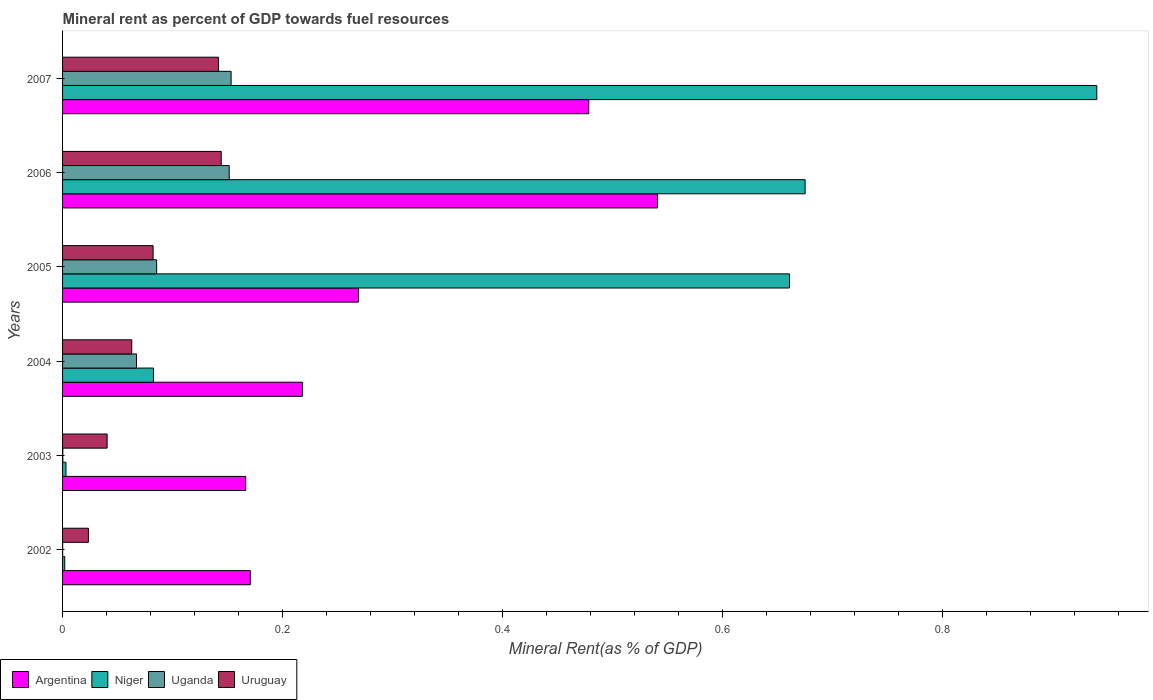How many different coloured bars are there?
Provide a short and direct response. 4. How many bars are there on the 3rd tick from the top?
Provide a succinct answer. 4. How many bars are there on the 1st tick from the bottom?
Give a very brief answer. 4. What is the mineral rent in Argentina in 2005?
Offer a terse response. 0.27. Across all years, what is the maximum mineral rent in Argentina?
Offer a terse response. 0.54. Across all years, what is the minimum mineral rent in Argentina?
Your response must be concise. 0.17. In which year was the mineral rent in Uruguay maximum?
Your answer should be compact. 2006. In which year was the mineral rent in Niger minimum?
Give a very brief answer. 2002. What is the total mineral rent in Argentina in the graph?
Keep it short and to the point. 1.84. What is the difference between the mineral rent in Uruguay in 2003 and that in 2004?
Ensure brevity in your answer.  -0.02. What is the difference between the mineral rent in Uganda in 2004 and the mineral rent in Niger in 2006?
Give a very brief answer. -0.61. What is the average mineral rent in Argentina per year?
Your response must be concise. 0.31. In the year 2006, what is the difference between the mineral rent in Uganda and mineral rent in Argentina?
Your answer should be compact. -0.39. In how many years, is the mineral rent in Argentina greater than 0.44 %?
Keep it short and to the point. 2. What is the ratio of the mineral rent in Uruguay in 2003 to that in 2006?
Provide a short and direct response. 0.28. Is the mineral rent in Argentina in 2004 less than that in 2005?
Keep it short and to the point. Yes. What is the difference between the highest and the second highest mineral rent in Niger?
Your answer should be compact. 0.27. What is the difference between the highest and the lowest mineral rent in Uganda?
Your answer should be compact. 0.15. What does the 2nd bar from the top in 2002 represents?
Ensure brevity in your answer.  Uganda. What does the 1st bar from the bottom in 2002 represents?
Provide a short and direct response. Argentina. Is it the case that in every year, the sum of the mineral rent in Uruguay and mineral rent in Argentina is greater than the mineral rent in Niger?
Make the answer very short. No. How many bars are there?
Give a very brief answer. 24. What is the difference between two consecutive major ticks on the X-axis?
Provide a succinct answer. 0.2. Does the graph contain grids?
Your answer should be compact. No. Where does the legend appear in the graph?
Ensure brevity in your answer.  Bottom left. What is the title of the graph?
Your answer should be very brief. Mineral rent as percent of GDP towards fuel resources. Does "Canada" appear as one of the legend labels in the graph?
Ensure brevity in your answer.  No. What is the label or title of the X-axis?
Keep it short and to the point. Mineral Rent(as % of GDP). What is the Mineral Rent(as % of GDP) of Argentina in 2002?
Provide a succinct answer. 0.17. What is the Mineral Rent(as % of GDP) of Niger in 2002?
Provide a short and direct response. 0. What is the Mineral Rent(as % of GDP) in Uganda in 2002?
Provide a short and direct response. 7.469620528345872e-5. What is the Mineral Rent(as % of GDP) of Uruguay in 2002?
Keep it short and to the point. 0.02. What is the Mineral Rent(as % of GDP) of Argentina in 2003?
Give a very brief answer. 0.17. What is the Mineral Rent(as % of GDP) in Niger in 2003?
Provide a short and direct response. 0. What is the Mineral Rent(as % of GDP) of Uganda in 2003?
Keep it short and to the point. 0. What is the Mineral Rent(as % of GDP) in Uruguay in 2003?
Provide a short and direct response. 0.04. What is the Mineral Rent(as % of GDP) in Argentina in 2004?
Provide a short and direct response. 0.22. What is the Mineral Rent(as % of GDP) in Niger in 2004?
Ensure brevity in your answer.  0.08. What is the Mineral Rent(as % of GDP) in Uganda in 2004?
Give a very brief answer. 0.07. What is the Mineral Rent(as % of GDP) in Uruguay in 2004?
Give a very brief answer. 0.06. What is the Mineral Rent(as % of GDP) in Argentina in 2005?
Offer a terse response. 0.27. What is the Mineral Rent(as % of GDP) in Niger in 2005?
Make the answer very short. 0.66. What is the Mineral Rent(as % of GDP) of Uganda in 2005?
Provide a succinct answer. 0.09. What is the Mineral Rent(as % of GDP) in Uruguay in 2005?
Make the answer very short. 0.08. What is the Mineral Rent(as % of GDP) of Argentina in 2006?
Offer a very short reply. 0.54. What is the Mineral Rent(as % of GDP) in Niger in 2006?
Give a very brief answer. 0.68. What is the Mineral Rent(as % of GDP) of Uganda in 2006?
Provide a succinct answer. 0.15. What is the Mineral Rent(as % of GDP) of Uruguay in 2006?
Provide a short and direct response. 0.14. What is the Mineral Rent(as % of GDP) of Argentina in 2007?
Your answer should be compact. 0.48. What is the Mineral Rent(as % of GDP) of Niger in 2007?
Your answer should be compact. 0.94. What is the Mineral Rent(as % of GDP) in Uganda in 2007?
Keep it short and to the point. 0.15. What is the Mineral Rent(as % of GDP) in Uruguay in 2007?
Keep it short and to the point. 0.14. Across all years, what is the maximum Mineral Rent(as % of GDP) of Argentina?
Give a very brief answer. 0.54. Across all years, what is the maximum Mineral Rent(as % of GDP) of Niger?
Provide a short and direct response. 0.94. Across all years, what is the maximum Mineral Rent(as % of GDP) in Uganda?
Your response must be concise. 0.15. Across all years, what is the maximum Mineral Rent(as % of GDP) of Uruguay?
Provide a short and direct response. 0.14. Across all years, what is the minimum Mineral Rent(as % of GDP) in Argentina?
Provide a short and direct response. 0.17. Across all years, what is the minimum Mineral Rent(as % of GDP) in Niger?
Offer a terse response. 0. Across all years, what is the minimum Mineral Rent(as % of GDP) in Uganda?
Make the answer very short. 7.469620528345872e-5. Across all years, what is the minimum Mineral Rent(as % of GDP) in Uruguay?
Your response must be concise. 0.02. What is the total Mineral Rent(as % of GDP) in Argentina in the graph?
Provide a short and direct response. 1.84. What is the total Mineral Rent(as % of GDP) of Niger in the graph?
Your answer should be compact. 2.36. What is the total Mineral Rent(as % of GDP) of Uganda in the graph?
Offer a terse response. 0.46. What is the total Mineral Rent(as % of GDP) in Uruguay in the graph?
Offer a very short reply. 0.5. What is the difference between the Mineral Rent(as % of GDP) in Argentina in 2002 and that in 2003?
Keep it short and to the point. 0. What is the difference between the Mineral Rent(as % of GDP) in Niger in 2002 and that in 2003?
Your answer should be compact. -0. What is the difference between the Mineral Rent(as % of GDP) in Uganda in 2002 and that in 2003?
Ensure brevity in your answer.  -0. What is the difference between the Mineral Rent(as % of GDP) of Uruguay in 2002 and that in 2003?
Offer a terse response. -0.02. What is the difference between the Mineral Rent(as % of GDP) in Argentina in 2002 and that in 2004?
Keep it short and to the point. -0.05. What is the difference between the Mineral Rent(as % of GDP) of Niger in 2002 and that in 2004?
Your answer should be very brief. -0.08. What is the difference between the Mineral Rent(as % of GDP) in Uganda in 2002 and that in 2004?
Offer a terse response. -0.07. What is the difference between the Mineral Rent(as % of GDP) of Uruguay in 2002 and that in 2004?
Your answer should be very brief. -0.04. What is the difference between the Mineral Rent(as % of GDP) of Argentina in 2002 and that in 2005?
Ensure brevity in your answer.  -0.1. What is the difference between the Mineral Rent(as % of GDP) of Niger in 2002 and that in 2005?
Provide a short and direct response. -0.66. What is the difference between the Mineral Rent(as % of GDP) of Uganda in 2002 and that in 2005?
Keep it short and to the point. -0.09. What is the difference between the Mineral Rent(as % of GDP) of Uruguay in 2002 and that in 2005?
Keep it short and to the point. -0.06. What is the difference between the Mineral Rent(as % of GDP) of Argentina in 2002 and that in 2006?
Offer a very short reply. -0.37. What is the difference between the Mineral Rent(as % of GDP) of Niger in 2002 and that in 2006?
Provide a short and direct response. -0.67. What is the difference between the Mineral Rent(as % of GDP) in Uganda in 2002 and that in 2006?
Keep it short and to the point. -0.15. What is the difference between the Mineral Rent(as % of GDP) of Uruguay in 2002 and that in 2006?
Offer a terse response. -0.12. What is the difference between the Mineral Rent(as % of GDP) of Argentina in 2002 and that in 2007?
Offer a terse response. -0.31. What is the difference between the Mineral Rent(as % of GDP) in Niger in 2002 and that in 2007?
Provide a succinct answer. -0.94. What is the difference between the Mineral Rent(as % of GDP) of Uganda in 2002 and that in 2007?
Make the answer very short. -0.15. What is the difference between the Mineral Rent(as % of GDP) of Uruguay in 2002 and that in 2007?
Make the answer very short. -0.12. What is the difference between the Mineral Rent(as % of GDP) in Argentina in 2003 and that in 2004?
Your answer should be very brief. -0.05. What is the difference between the Mineral Rent(as % of GDP) in Niger in 2003 and that in 2004?
Provide a succinct answer. -0.08. What is the difference between the Mineral Rent(as % of GDP) in Uganda in 2003 and that in 2004?
Your response must be concise. -0.07. What is the difference between the Mineral Rent(as % of GDP) in Uruguay in 2003 and that in 2004?
Make the answer very short. -0.02. What is the difference between the Mineral Rent(as % of GDP) of Argentina in 2003 and that in 2005?
Provide a succinct answer. -0.1. What is the difference between the Mineral Rent(as % of GDP) in Niger in 2003 and that in 2005?
Offer a terse response. -0.66. What is the difference between the Mineral Rent(as % of GDP) in Uganda in 2003 and that in 2005?
Keep it short and to the point. -0.09. What is the difference between the Mineral Rent(as % of GDP) in Uruguay in 2003 and that in 2005?
Your answer should be compact. -0.04. What is the difference between the Mineral Rent(as % of GDP) of Argentina in 2003 and that in 2006?
Provide a succinct answer. -0.37. What is the difference between the Mineral Rent(as % of GDP) of Niger in 2003 and that in 2006?
Provide a short and direct response. -0.67. What is the difference between the Mineral Rent(as % of GDP) in Uganda in 2003 and that in 2006?
Your answer should be compact. -0.15. What is the difference between the Mineral Rent(as % of GDP) of Uruguay in 2003 and that in 2006?
Offer a terse response. -0.1. What is the difference between the Mineral Rent(as % of GDP) of Argentina in 2003 and that in 2007?
Your response must be concise. -0.31. What is the difference between the Mineral Rent(as % of GDP) in Niger in 2003 and that in 2007?
Your answer should be very brief. -0.94. What is the difference between the Mineral Rent(as % of GDP) in Uganda in 2003 and that in 2007?
Offer a terse response. -0.15. What is the difference between the Mineral Rent(as % of GDP) in Uruguay in 2003 and that in 2007?
Your response must be concise. -0.1. What is the difference between the Mineral Rent(as % of GDP) of Argentina in 2004 and that in 2005?
Make the answer very short. -0.05. What is the difference between the Mineral Rent(as % of GDP) of Niger in 2004 and that in 2005?
Make the answer very short. -0.58. What is the difference between the Mineral Rent(as % of GDP) of Uganda in 2004 and that in 2005?
Provide a succinct answer. -0.02. What is the difference between the Mineral Rent(as % of GDP) in Uruguay in 2004 and that in 2005?
Your answer should be very brief. -0.02. What is the difference between the Mineral Rent(as % of GDP) of Argentina in 2004 and that in 2006?
Provide a succinct answer. -0.32. What is the difference between the Mineral Rent(as % of GDP) of Niger in 2004 and that in 2006?
Your answer should be compact. -0.59. What is the difference between the Mineral Rent(as % of GDP) in Uganda in 2004 and that in 2006?
Ensure brevity in your answer.  -0.08. What is the difference between the Mineral Rent(as % of GDP) of Uruguay in 2004 and that in 2006?
Provide a succinct answer. -0.08. What is the difference between the Mineral Rent(as % of GDP) of Argentina in 2004 and that in 2007?
Your answer should be compact. -0.26. What is the difference between the Mineral Rent(as % of GDP) of Niger in 2004 and that in 2007?
Your answer should be compact. -0.86. What is the difference between the Mineral Rent(as % of GDP) in Uganda in 2004 and that in 2007?
Your response must be concise. -0.09. What is the difference between the Mineral Rent(as % of GDP) in Uruguay in 2004 and that in 2007?
Your answer should be compact. -0.08. What is the difference between the Mineral Rent(as % of GDP) of Argentina in 2005 and that in 2006?
Make the answer very short. -0.27. What is the difference between the Mineral Rent(as % of GDP) in Niger in 2005 and that in 2006?
Offer a terse response. -0.01. What is the difference between the Mineral Rent(as % of GDP) of Uganda in 2005 and that in 2006?
Your answer should be very brief. -0.07. What is the difference between the Mineral Rent(as % of GDP) of Uruguay in 2005 and that in 2006?
Provide a succinct answer. -0.06. What is the difference between the Mineral Rent(as % of GDP) of Argentina in 2005 and that in 2007?
Give a very brief answer. -0.21. What is the difference between the Mineral Rent(as % of GDP) of Niger in 2005 and that in 2007?
Make the answer very short. -0.28. What is the difference between the Mineral Rent(as % of GDP) in Uganda in 2005 and that in 2007?
Your answer should be compact. -0.07. What is the difference between the Mineral Rent(as % of GDP) of Uruguay in 2005 and that in 2007?
Offer a terse response. -0.06. What is the difference between the Mineral Rent(as % of GDP) in Argentina in 2006 and that in 2007?
Provide a succinct answer. 0.06. What is the difference between the Mineral Rent(as % of GDP) of Niger in 2006 and that in 2007?
Make the answer very short. -0.27. What is the difference between the Mineral Rent(as % of GDP) in Uganda in 2006 and that in 2007?
Give a very brief answer. -0. What is the difference between the Mineral Rent(as % of GDP) in Uruguay in 2006 and that in 2007?
Offer a terse response. 0. What is the difference between the Mineral Rent(as % of GDP) in Argentina in 2002 and the Mineral Rent(as % of GDP) in Niger in 2003?
Make the answer very short. 0.17. What is the difference between the Mineral Rent(as % of GDP) of Argentina in 2002 and the Mineral Rent(as % of GDP) of Uganda in 2003?
Offer a very short reply. 0.17. What is the difference between the Mineral Rent(as % of GDP) in Argentina in 2002 and the Mineral Rent(as % of GDP) in Uruguay in 2003?
Make the answer very short. 0.13. What is the difference between the Mineral Rent(as % of GDP) of Niger in 2002 and the Mineral Rent(as % of GDP) of Uganda in 2003?
Your answer should be compact. 0. What is the difference between the Mineral Rent(as % of GDP) in Niger in 2002 and the Mineral Rent(as % of GDP) in Uruguay in 2003?
Give a very brief answer. -0.04. What is the difference between the Mineral Rent(as % of GDP) of Uganda in 2002 and the Mineral Rent(as % of GDP) of Uruguay in 2003?
Offer a terse response. -0.04. What is the difference between the Mineral Rent(as % of GDP) in Argentina in 2002 and the Mineral Rent(as % of GDP) in Niger in 2004?
Provide a short and direct response. 0.09. What is the difference between the Mineral Rent(as % of GDP) in Argentina in 2002 and the Mineral Rent(as % of GDP) in Uganda in 2004?
Keep it short and to the point. 0.1. What is the difference between the Mineral Rent(as % of GDP) of Argentina in 2002 and the Mineral Rent(as % of GDP) of Uruguay in 2004?
Give a very brief answer. 0.11. What is the difference between the Mineral Rent(as % of GDP) in Niger in 2002 and the Mineral Rent(as % of GDP) in Uganda in 2004?
Your response must be concise. -0.07. What is the difference between the Mineral Rent(as % of GDP) in Niger in 2002 and the Mineral Rent(as % of GDP) in Uruguay in 2004?
Your response must be concise. -0.06. What is the difference between the Mineral Rent(as % of GDP) in Uganda in 2002 and the Mineral Rent(as % of GDP) in Uruguay in 2004?
Offer a terse response. -0.06. What is the difference between the Mineral Rent(as % of GDP) of Argentina in 2002 and the Mineral Rent(as % of GDP) of Niger in 2005?
Make the answer very short. -0.49. What is the difference between the Mineral Rent(as % of GDP) of Argentina in 2002 and the Mineral Rent(as % of GDP) of Uganda in 2005?
Offer a very short reply. 0.09. What is the difference between the Mineral Rent(as % of GDP) in Argentina in 2002 and the Mineral Rent(as % of GDP) in Uruguay in 2005?
Offer a very short reply. 0.09. What is the difference between the Mineral Rent(as % of GDP) of Niger in 2002 and the Mineral Rent(as % of GDP) of Uganda in 2005?
Ensure brevity in your answer.  -0.08. What is the difference between the Mineral Rent(as % of GDP) in Niger in 2002 and the Mineral Rent(as % of GDP) in Uruguay in 2005?
Offer a very short reply. -0.08. What is the difference between the Mineral Rent(as % of GDP) in Uganda in 2002 and the Mineral Rent(as % of GDP) in Uruguay in 2005?
Make the answer very short. -0.08. What is the difference between the Mineral Rent(as % of GDP) of Argentina in 2002 and the Mineral Rent(as % of GDP) of Niger in 2006?
Your answer should be very brief. -0.5. What is the difference between the Mineral Rent(as % of GDP) in Argentina in 2002 and the Mineral Rent(as % of GDP) in Uganda in 2006?
Your response must be concise. 0.02. What is the difference between the Mineral Rent(as % of GDP) of Argentina in 2002 and the Mineral Rent(as % of GDP) of Uruguay in 2006?
Offer a very short reply. 0.03. What is the difference between the Mineral Rent(as % of GDP) in Niger in 2002 and the Mineral Rent(as % of GDP) in Uganda in 2006?
Keep it short and to the point. -0.15. What is the difference between the Mineral Rent(as % of GDP) in Niger in 2002 and the Mineral Rent(as % of GDP) in Uruguay in 2006?
Provide a succinct answer. -0.14. What is the difference between the Mineral Rent(as % of GDP) in Uganda in 2002 and the Mineral Rent(as % of GDP) in Uruguay in 2006?
Keep it short and to the point. -0.14. What is the difference between the Mineral Rent(as % of GDP) in Argentina in 2002 and the Mineral Rent(as % of GDP) in Niger in 2007?
Offer a terse response. -0.77. What is the difference between the Mineral Rent(as % of GDP) of Argentina in 2002 and the Mineral Rent(as % of GDP) of Uganda in 2007?
Your answer should be compact. 0.02. What is the difference between the Mineral Rent(as % of GDP) of Argentina in 2002 and the Mineral Rent(as % of GDP) of Uruguay in 2007?
Your response must be concise. 0.03. What is the difference between the Mineral Rent(as % of GDP) in Niger in 2002 and the Mineral Rent(as % of GDP) in Uganda in 2007?
Keep it short and to the point. -0.15. What is the difference between the Mineral Rent(as % of GDP) of Niger in 2002 and the Mineral Rent(as % of GDP) of Uruguay in 2007?
Ensure brevity in your answer.  -0.14. What is the difference between the Mineral Rent(as % of GDP) of Uganda in 2002 and the Mineral Rent(as % of GDP) of Uruguay in 2007?
Your response must be concise. -0.14. What is the difference between the Mineral Rent(as % of GDP) of Argentina in 2003 and the Mineral Rent(as % of GDP) of Niger in 2004?
Your response must be concise. 0.08. What is the difference between the Mineral Rent(as % of GDP) of Argentina in 2003 and the Mineral Rent(as % of GDP) of Uganda in 2004?
Ensure brevity in your answer.  0.1. What is the difference between the Mineral Rent(as % of GDP) in Argentina in 2003 and the Mineral Rent(as % of GDP) in Uruguay in 2004?
Your answer should be very brief. 0.1. What is the difference between the Mineral Rent(as % of GDP) in Niger in 2003 and the Mineral Rent(as % of GDP) in Uganda in 2004?
Provide a succinct answer. -0.06. What is the difference between the Mineral Rent(as % of GDP) of Niger in 2003 and the Mineral Rent(as % of GDP) of Uruguay in 2004?
Offer a very short reply. -0.06. What is the difference between the Mineral Rent(as % of GDP) in Uganda in 2003 and the Mineral Rent(as % of GDP) in Uruguay in 2004?
Keep it short and to the point. -0.06. What is the difference between the Mineral Rent(as % of GDP) in Argentina in 2003 and the Mineral Rent(as % of GDP) in Niger in 2005?
Give a very brief answer. -0.49. What is the difference between the Mineral Rent(as % of GDP) in Argentina in 2003 and the Mineral Rent(as % of GDP) in Uganda in 2005?
Your answer should be compact. 0.08. What is the difference between the Mineral Rent(as % of GDP) of Argentina in 2003 and the Mineral Rent(as % of GDP) of Uruguay in 2005?
Your response must be concise. 0.08. What is the difference between the Mineral Rent(as % of GDP) in Niger in 2003 and the Mineral Rent(as % of GDP) in Uganda in 2005?
Ensure brevity in your answer.  -0.08. What is the difference between the Mineral Rent(as % of GDP) of Niger in 2003 and the Mineral Rent(as % of GDP) of Uruguay in 2005?
Your answer should be compact. -0.08. What is the difference between the Mineral Rent(as % of GDP) in Uganda in 2003 and the Mineral Rent(as % of GDP) in Uruguay in 2005?
Your answer should be compact. -0.08. What is the difference between the Mineral Rent(as % of GDP) of Argentina in 2003 and the Mineral Rent(as % of GDP) of Niger in 2006?
Ensure brevity in your answer.  -0.51. What is the difference between the Mineral Rent(as % of GDP) in Argentina in 2003 and the Mineral Rent(as % of GDP) in Uganda in 2006?
Your answer should be very brief. 0.01. What is the difference between the Mineral Rent(as % of GDP) of Argentina in 2003 and the Mineral Rent(as % of GDP) of Uruguay in 2006?
Offer a terse response. 0.02. What is the difference between the Mineral Rent(as % of GDP) in Niger in 2003 and the Mineral Rent(as % of GDP) in Uganda in 2006?
Make the answer very short. -0.15. What is the difference between the Mineral Rent(as % of GDP) in Niger in 2003 and the Mineral Rent(as % of GDP) in Uruguay in 2006?
Ensure brevity in your answer.  -0.14. What is the difference between the Mineral Rent(as % of GDP) of Uganda in 2003 and the Mineral Rent(as % of GDP) of Uruguay in 2006?
Offer a very short reply. -0.14. What is the difference between the Mineral Rent(as % of GDP) in Argentina in 2003 and the Mineral Rent(as % of GDP) in Niger in 2007?
Make the answer very short. -0.77. What is the difference between the Mineral Rent(as % of GDP) of Argentina in 2003 and the Mineral Rent(as % of GDP) of Uganda in 2007?
Ensure brevity in your answer.  0.01. What is the difference between the Mineral Rent(as % of GDP) of Argentina in 2003 and the Mineral Rent(as % of GDP) of Uruguay in 2007?
Keep it short and to the point. 0.02. What is the difference between the Mineral Rent(as % of GDP) of Niger in 2003 and the Mineral Rent(as % of GDP) of Uganda in 2007?
Offer a very short reply. -0.15. What is the difference between the Mineral Rent(as % of GDP) in Niger in 2003 and the Mineral Rent(as % of GDP) in Uruguay in 2007?
Keep it short and to the point. -0.14. What is the difference between the Mineral Rent(as % of GDP) of Uganda in 2003 and the Mineral Rent(as % of GDP) of Uruguay in 2007?
Give a very brief answer. -0.14. What is the difference between the Mineral Rent(as % of GDP) in Argentina in 2004 and the Mineral Rent(as % of GDP) in Niger in 2005?
Your response must be concise. -0.44. What is the difference between the Mineral Rent(as % of GDP) of Argentina in 2004 and the Mineral Rent(as % of GDP) of Uganda in 2005?
Your response must be concise. 0.13. What is the difference between the Mineral Rent(as % of GDP) of Argentina in 2004 and the Mineral Rent(as % of GDP) of Uruguay in 2005?
Your response must be concise. 0.14. What is the difference between the Mineral Rent(as % of GDP) in Niger in 2004 and the Mineral Rent(as % of GDP) in Uganda in 2005?
Offer a very short reply. -0. What is the difference between the Mineral Rent(as % of GDP) of Uganda in 2004 and the Mineral Rent(as % of GDP) of Uruguay in 2005?
Ensure brevity in your answer.  -0.02. What is the difference between the Mineral Rent(as % of GDP) of Argentina in 2004 and the Mineral Rent(as % of GDP) of Niger in 2006?
Give a very brief answer. -0.46. What is the difference between the Mineral Rent(as % of GDP) in Argentina in 2004 and the Mineral Rent(as % of GDP) in Uganda in 2006?
Your answer should be very brief. 0.07. What is the difference between the Mineral Rent(as % of GDP) of Argentina in 2004 and the Mineral Rent(as % of GDP) of Uruguay in 2006?
Your response must be concise. 0.07. What is the difference between the Mineral Rent(as % of GDP) in Niger in 2004 and the Mineral Rent(as % of GDP) in Uganda in 2006?
Offer a terse response. -0.07. What is the difference between the Mineral Rent(as % of GDP) of Niger in 2004 and the Mineral Rent(as % of GDP) of Uruguay in 2006?
Provide a short and direct response. -0.06. What is the difference between the Mineral Rent(as % of GDP) in Uganda in 2004 and the Mineral Rent(as % of GDP) in Uruguay in 2006?
Your answer should be compact. -0.08. What is the difference between the Mineral Rent(as % of GDP) of Argentina in 2004 and the Mineral Rent(as % of GDP) of Niger in 2007?
Your answer should be compact. -0.72. What is the difference between the Mineral Rent(as % of GDP) of Argentina in 2004 and the Mineral Rent(as % of GDP) of Uganda in 2007?
Keep it short and to the point. 0.06. What is the difference between the Mineral Rent(as % of GDP) of Argentina in 2004 and the Mineral Rent(as % of GDP) of Uruguay in 2007?
Give a very brief answer. 0.08. What is the difference between the Mineral Rent(as % of GDP) in Niger in 2004 and the Mineral Rent(as % of GDP) in Uganda in 2007?
Make the answer very short. -0.07. What is the difference between the Mineral Rent(as % of GDP) in Niger in 2004 and the Mineral Rent(as % of GDP) in Uruguay in 2007?
Provide a succinct answer. -0.06. What is the difference between the Mineral Rent(as % of GDP) in Uganda in 2004 and the Mineral Rent(as % of GDP) in Uruguay in 2007?
Ensure brevity in your answer.  -0.07. What is the difference between the Mineral Rent(as % of GDP) in Argentina in 2005 and the Mineral Rent(as % of GDP) in Niger in 2006?
Provide a short and direct response. -0.41. What is the difference between the Mineral Rent(as % of GDP) of Argentina in 2005 and the Mineral Rent(as % of GDP) of Uganda in 2006?
Keep it short and to the point. 0.12. What is the difference between the Mineral Rent(as % of GDP) in Argentina in 2005 and the Mineral Rent(as % of GDP) in Uruguay in 2006?
Make the answer very short. 0.12. What is the difference between the Mineral Rent(as % of GDP) of Niger in 2005 and the Mineral Rent(as % of GDP) of Uganda in 2006?
Give a very brief answer. 0.51. What is the difference between the Mineral Rent(as % of GDP) of Niger in 2005 and the Mineral Rent(as % of GDP) of Uruguay in 2006?
Keep it short and to the point. 0.52. What is the difference between the Mineral Rent(as % of GDP) of Uganda in 2005 and the Mineral Rent(as % of GDP) of Uruguay in 2006?
Provide a short and direct response. -0.06. What is the difference between the Mineral Rent(as % of GDP) of Argentina in 2005 and the Mineral Rent(as % of GDP) of Niger in 2007?
Give a very brief answer. -0.67. What is the difference between the Mineral Rent(as % of GDP) in Argentina in 2005 and the Mineral Rent(as % of GDP) in Uganda in 2007?
Make the answer very short. 0.12. What is the difference between the Mineral Rent(as % of GDP) in Argentina in 2005 and the Mineral Rent(as % of GDP) in Uruguay in 2007?
Keep it short and to the point. 0.13. What is the difference between the Mineral Rent(as % of GDP) in Niger in 2005 and the Mineral Rent(as % of GDP) in Uganda in 2007?
Ensure brevity in your answer.  0.51. What is the difference between the Mineral Rent(as % of GDP) of Niger in 2005 and the Mineral Rent(as % of GDP) of Uruguay in 2007?
Your answer should be very brief. 0.52. What is the difference between the Mineral Rent(as % of GDP) of Uganda in 2005 and the Mineral Rent(as % of GDP) of Uruguay in 2007?
Give a very brief answer. -0.06. What is the difference between the Mineral Rent(as % of GDP) of Argentina in 2006 and the Mineral Rent(as % of GDP) of Niger in 2007?
Your answer should be very brief. -0.4. What is the difference between the Mineral Rent(as % of GDP) of Argentina in 2006 and the Mineral Rent(as % of GDP) of Uganda in 2007?
Make the answer very short. 0.39. What is the difference between the Mineral Rent(as % of GDP) of Argentina in 2006 and the Mineral Rent(as % of GDP) of Uruguay in 2007?
Make the answer very short. 0.4. What is the difference between the Mineral Rent(as % of GDP) of Niger in 2006 and the Mineral Rent(as % of GDP) of Uganda in 2007?
Your answer should be very brief. 0.52. What is the difference between the Mineral Rent(as % of GDP) in Niger in 2006 and the Mineral Rent(as % of GDP) in Uruguay in 2007?
Your response must be concise. 0.53. What is the difference between the Mineral Rent(as % of GDP) in Uganda in 2006 and the Mineral Rent(as % of GDP) in Uruguay in 2007?
Give a very brief answer. 0.01. What is the average Mineral Rent(as % of GDP) in Argentina per year?
Ensure brevity in your answer.  0.31. What is the average Mineral Rent(as % of GDP) in Niger per year?
Offer a very short reply. 0.39. What is the average Mineral Rent(as % of GDP) of Uganda per year?
Keep it short and to the point. 0.08. What is the average Mineral Rent(as % of GDP) in Uruguay per year?
Give a very brief answer. 0.08. In the year 2002, what is the difference between the Mineral Rent(as % of GDP) in Argentina and Mineral Rent(as % of GDP) in Niger?
Provide a succinct answer. 0.17. In the year 2002, what is the difference between the Mineral Rent(as % of GDP) of Argentina and Mineral Rent(as % of GDP) of Uganda?
Keep it short and to the point. 0.17. In the year 2002, what is the difference between the Mineral Rent(as % of GDP) of Argentina and Mineral Rent(as % of GDP) of Uruguay?
Provide a short and direct response. 0.15. In the year 2002, what is the difference between the Mineral Rent(as % of GDP) of Niger and Mineral Rent(as % of GDP) of Uganda?
Offer a very short reply. 0. In the year 2002, what is the difference between the Mineral Rent(as % of GDP) of Niger and Mineral Rent(as % of GDP) of Uruguay?
Provide a succinct answer. -0.02. In the year 2002, what is the difference between the Mineral Rent(as % of GDP) of Uganda and Mineral Rent(as % of GDP) of Uruguay?
Give a very brief answer. -0.02. In the year 2003, what is the difference between the Mineral Rent(as % of GDP) of Argentina and Mineral Rent(as % of GDP) of Niger?
Provide a succinct answer. 0.16. In the year 2003, what is the difference between the Mineral Rent(as % of GDP) of Argentina and Mineral Rent(as % of GDP) of Uganda?
Make the answer very short. 0.17. In the year 2003, what is the difference between the Mineral Rent(as % of GDP) of Argentina and Mineral Rent(as % of GDP) of Uruguay?
Give a very brief answer. 0.13. In the year 2003, what is the difference between the Mineral Rent(as % of GDP) of Niger and Mineral Rent(as % of GDP) of Uganda?
Provide a succinct answer. 0. In the year 2003, what is the difference between the Mineral Rent(as % of GDP) in Niger and Mineral Rent(as % of GDP) in Uruguay?
Ensure brevity in your answer.  -0.04. In the year 2003, what is the difference between the Mineral Rent(as % of GDP) in Uganda and Mineral Rent(as % of GDP) in Uruguay?
Offer a very short reply. -0.04. In the year 2004, what is the difference between the Mineral Rent(as % of GDP) in Argentina and Mineral Rent(as % of GDP) in Niger?
Your answer should be very brief. 0.14. In the year 2004, what is the difference between the Mineral Rent(as % of GDP) in Argentina and Mineral Rent(as % of GDP) in Uganda?
Offer a terse response. 0.15. In the year 2004, what is the difference between the Mineral Rent(as % of GDP) in Argentina and Mineral Rent(as % of GDP) in Uruguay?
Provide a succinct answer. 0.16. In the year 2004, what is the difference between the Mineral Rent(as % of GDP) of Niger and Mineral Rent(as % of GDP) of Uganda?
Provide a short and direct response. 0.02. In the year 2004, what is the difference between the Mineral Rent(as % of GDP) in Niger and Mineral Rent(as % of GDP) in Uruguay?
Ensure brevity in your answer.  0.02. In the year 2004, what is the difference between the Mineral Rent(as % of GDP) of Uganda and Mineral Rent(as % of GDP) of Uruguay?
Your response must be concise. 0. In the year 2005, what is the difference between the Mineral Rent(as % of GDP) in Argentina and Mineral Rent(as % of GDP) in Niger?
Offer a terse response. -0.39. In the year 2005, what is the difference between the Mineral Rent(as % of GDP) in Argentina and Mineral Rent(as % of GDP) in Uganda?
Offer a very short reply. 0.18. In the year 2005, what is the difference between the Mineral Rent(as % of GDP) in Argentina and Mineral Rent(as % of GDP) in Uruguay?
Your response must be concise. 0.19. In the year 2005, what is the difference between the Mineral Rent(as % of GDP) of Niger and Mineral Rent(as % of GDP) of Uganda?
Your response must be concise. 0.58. In the year 2005, what is the difference between the Mineral Rent(as % of GDP) of Niger and Mineral Rent(as % of GDP) of Uruguay?
Give a very brief answer. 0.58. In the year 2005, what is the difference between the Mineral Rent(as % of GDP) in Uganda and Mineral Rent(as % of GDP) in Uruguay?
Your response must be concise. 0. In the year 2006, what is the difference between the Mineral Rent(as % of GDP) of Argentina and Mineral Rent(as % of GDP) of Niger?
Make the answer very short. -0.13. In the year 2006, what is the difference between the Mineral Rent(as % of GDP) in Argentina and Mineral Rent(as % of GDP) in Uganda?
Offer a terse response. 0.39. In the year 2006, what is the difference between the Mineral Rent(as % of GDP) of Argentina and Mineral Rent(as % of GDP) of Uruguay?
Your response must be concise. 0.4. In the year 2006, what is the difference between the Mineral Rent(as % of GDP) of Niger and Mineral Rent(as % of GDP) of Uganda?
Ensure brevity in your answer.  0.52. In the year 2006, what is the difference between the Mineral Rent(as % of GDP) in Niger and Mineral Rent(as % of GDP) in Uruguay?
Ensure brevity in your answer.  0.53. In the year 2006, what is the difference between the Mineral Rent(as % of GDP) in Uganda and Mineral Rent(as % of GDP) in Uruguay?
Your response must be concise. 0.01. In the year 2007, what is the difference between the Mineral Rent(as % of GDP) of Argentina and Mineral Rent(as % of GDP) of Niger?
Provide a short and direct response. -0.46. In the year 2007, what is the difference between the Mineral Rent(as % of GDP) in Argentina and Mineral Rent(as % of GDP) in Uganda?
Offer a very short reply. 0.33. In the year 2007, what is the difference between the Mineral Rent(as % of GDP) in Argentina and Mineral Rent(as % of GDP) in Uruguay?
Offer a terse response. 0.34. In the year 2007, what is the difference between the Mineral Rent(as % of GDP) in Niger and Mineral Rent(as % of GDP) in Uganda?
Provide a succinct answer. 0.79. In the year 2007, what is the difference between the Mineral Rent(as % of GDP) in Niger and Mineral Rent(as % of GDP) in Uruguay?
Offer a very short reply. 0.8. In the year 2007, what is the difference between the Mineral Rent(as % of GDP) in Uganda and Mineral Rent(as % of GDP) in Uruguay?
Your answer should be very brief. 0.01. What is the ratio of the Mineral Rent(as % of GDP) of Argentina in 2002 to that in 2003?
Offer a terse response. 1.03. What is the ratio of the Mineral Rent(as % of GDP) in Niger in 2002 to that in 2003?
Your response must be concise. 0.64. What is the ratio of the Mineral Rent(as % of GDP) in Uganda in 2002 to that in 2003?
Give a very brief answer. 0.34. What is the ratio of the Mineral Rent(as % of GDP) of Uruguay in 2002 to that in 2003?
Offer a very short reply. 0.58. What is the ratio of the Mineral Rent(as % of GDP) of Argentina in 2002 to that in 2004?
Offer a very short reply. 0.78. What is the ratio of the Mineral Rent(as % of GDP) of Niger in 2002 to that in 2004?
Give a very brief answer. 0.02. What is the ratio of the Mineral Rent(as % of GDP) of Uganda in 2002 to that in 2004?
Make the answer very short. 0. What is the ratio of the Mineral Rent(as % of GDP) of Uruguay in 2002 to that in 2004?
Provide a succinct answer. 0.37. What is the ratio of the Mineral Rent(as % of GDP) in Argentina in 2002 to that in 2005?
Give a very brief answer. 0.63. What is the ratio of the Mineral Rent(as % of GDP) in Niger in 2002 to that in 2005?
Keep it short and to the point. 0. What is the ratio of the Mineral Rent(as % of GDP) of Uganda in 2002 to that in 2005?
Offer a terse response. 0. What is the ratio of the Mineral Rent(as % of GDP) in Uruguay in 2002 to that in 2005?
Ensure brevity in your answer.  0.29. What is the ratio of the Mineral Rent(as % of GDP) of Argentina in 2002 to that in 2006?
Ensure brevity in your answer.  0.32. What is the ratio of the Mineral Rent(as % of GDP) of Niger in 2002 to that in 2006?
Keep it short and to the point. 0. What is the ratio of the Mineral Rent(as % of GDP) in Uruguay in 2002 to that in 2006?
Keep it short and to the point. 0.16. What is the ratio of the Mineral Rent(as % of GDP) in Argentina in 2002 to that in 2007?
Ensure brevity in your answer.  0.36. What is the ratio of the Mineral Rent(as % of GDP) in Niger in 2002 to that in 2007?
Make the answer very short. 0. What is the ratio of the Mineral Rent(as % of GDP) of Uruguay in 2002 to that in 2007?
Your answer should be compact. 0.17. What is the ratio of the Mineral Rent(as % of GDP) in Argentina in 2003 to that in 2004?
Your answer should be very brief. 0.76. What is the ratio of the Mineral Rent(as % of GDP) of Niger in 2003 to that in 2004?
Your answer should be compact. 0.04. What is the ratio of the Mineral Rent(as % of GDP) of Uganda in 2003 to that in 2004?
Your response must be concise. 0. What is the ratio of the Mineral Rent(as % of GDP) of Uruguay in 2003 to that in 2004?
Offer a terse response. 0.64. What is the ratio of the Mineral Rent(as % of GDP) of Argentina in 2003 to that in 2005?
Provide a succinct answer. 0.62. What is the ratio of the Mineral Rent(as % of GDP) of Niger in 2003 to that in 2005?
Your answer should be very brief. 0. What is the ratio of the Mineral Rent(as % of GDP) of Uganda in 2003 to that in 2005?
Give a very brief answer. 0. What is the ratio of the Mineral Rent(as % of GDP) in Uruguay in 2003 to that in 2005?
Offer a very short reply. 0.49. What is the ratio of the Mineral Rent(as % of GDP) of Argentina in 2003 to that in 2006?
Offer a terse response. 0.31. What is the ratio of the Mineral Rent(as % of GDP) in Niger in 2003 to that in 2006?
Your answer should be very brief. 0. What is the ratio of the Mineral Rent(as % of GDP) of Uganda in 2003 to that in 2006?
Your answer should be compact. 0. What is the ratio of the Mineral Rent(as % of GDP) of Uruguay in 2003 to that in 2006?
Offer a terse response. 0.28. What is the ratio of the Mineral Rent(as % of GDP) in Argentina in 2003 to that in 2007?
Offer a very short reply. 0.35. What is the ratio of the Mineral Rent(as % of GDP) in Niger in 2003 to that in 2007?
Ensure brevity in your answer.  0. What is the ratio of the Mineral Rent(as % of GDP) of Uganda in 2003 to that in 2007?
Your response must be concise. 0. What is the ratio of the Mineral Rent(as % of GDP) in Uruguay in 2003 to that in 2007?
Make the answer very short. 0.29. What is the ratio of the Mineral Rent(as % of GDP) in Argentina in 2004 to that in 2005?
Provide a succinct answer. 0.81. What is the ratio of the Mineral Rent(as % of GDP) of Uganda in 2004 to that in 2005?
Provide a succinct answer. 0.79. What is the ratio of the Mineral Rent(as % of GDP) of Uruguay in 2004 to that in 2005?
Provide a succinct answer. 0.76. What is the ratio of the Mineral Rent(as % of GDP) in Argentina in 2004 to that in 2006?
Give a very brief answer. 0.4. What is the ratio of the Mineral Rent(as % of GDP) in Niger in 2004 to that in 2006?
Offer a very short reply. 0.12. What is the ratio of the Mineral Rent(as % of GDP) of Uganda in 2004 to that in 2006?
Give a very brief answer. 0.44. What is the ratio of the Mineral Rent(as % of GDP) of Uruguay in 2004 to that in 2006?
Your answer should be very brief. 0.44. What is the ratio of the Mineral Rent(as % of GDP) in Argentina in 2004 to that in 2007?
Your answer should be compact. 0.46. What is the ratio of the Mineral Rent(as % of GDP) of Niger in 2004 to that in 2007?
Your response must be concise. 0.09. What is the ratio of the Mineral Rent(as % of GDP) of Uganda in 2004 to that in 2007?
Keep it short and to the point. 0.44. What is the ratio of the Mineral Rent(as % of GDP) in Uruguay in 2004 to that in 2007?
Give a very brief answer. 0.44. What is the ratio of the Mineral Rent(as % of GDP) in Argentina in 2005 to that in 2006?
Make the answer very short. 0.5. What is the ratio of the Mineral Rent(as % of GDP) in Niger in 2005 to that in 2006?
Provide a short and direct response. 0.98. What is the ratio of the Mineral Rent(as % of GDP) in Uganda in 2005 to that in 2006?
Provide a succinct answer. 0.56. What is the ratio of the Mineral Rent(as % of GDP) in Uruguay in 2005 to that in 2006?
Ensure brevity in your answer.  0.57. What is the ratio of the Mineral Rent(as % of GDP) of Argentina in 2005 to that in 2007?
Offer a very short reply. 0.56. What is the ratio of the Mineral Rent(as % of GDP) in Niger in 2005 to that in 2007?
Give a very brief answer. 0.7. What is the ratio of the Mineral Rent(as % of GDP) of Uganda in 2005 to that in 2007?
Ensure brevity in your answer.  0.56. What is the ratio of the Mineral Rent(as % of GDP) of Uruguay in 2005 to that in 2007?
Your response must be concise. 0.58. What is the ratio of the Mineral Rent(as % of GDP) in Argentina in 2006 to that in 2007?
Provide a short and direct response. 1.13. What is the ratio of the Mineral Rent(as % of GDP) of Niger in 2006 to that in 2007?
Provide a short and direct response. 0.72. What is the ratio of the Mineral Rent(as % of GDP) of Uganda in 2006 to that in 2007?
Your response must be concise. 0.99. What is the ratio of the Mineral Rent(as % of GDP) in Uruguay in 2006 to that in 2007?
Provide a succinct answer. 1.02. What is the difference between the highest and the second highest Mineral Rent(as % of GDP) of Argentina?
Provide a succinct answer. 0.06. What is the difference between the highest and the second highest Mineral Rent(as % of GDP) in Niger?
Ensure brevity in your answer.  0.27. What is the difference between the highest and the second highest Mineral Rent(as % of GDP) of Uganda?
Keep it short and to the point. 0. What is the difference between the highest and the second highest Mineral Rent(as % of GDP) of Uruguay?
Give a very brief answer. 0. What is the difference between the highest and the lowest Mineral Rent(as % of GDP) of Argentina?
Offer a terse response. 0.37. What is the difference between the highest and the lowest Mineral Rent(as % of GDP) of Niger?
Give a very brief answer. 0.94. What is the difference between the highest and the lowest Mineral Rent(as % of GDP) of Uganda?
Your answer should be compact. 0.15. What is the difference between the highest and the lowest Mineral Rent(as % of GDP) in Uruguay?
Offer a very short reply. 0.12. 